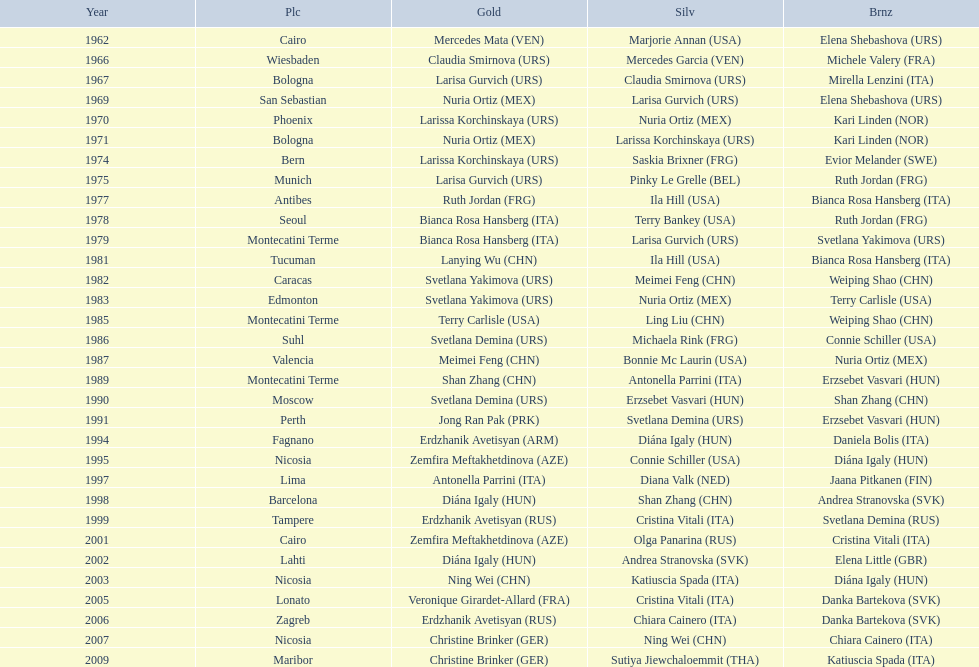Who won the only gold medal in 1962? Mercedes Mata. 